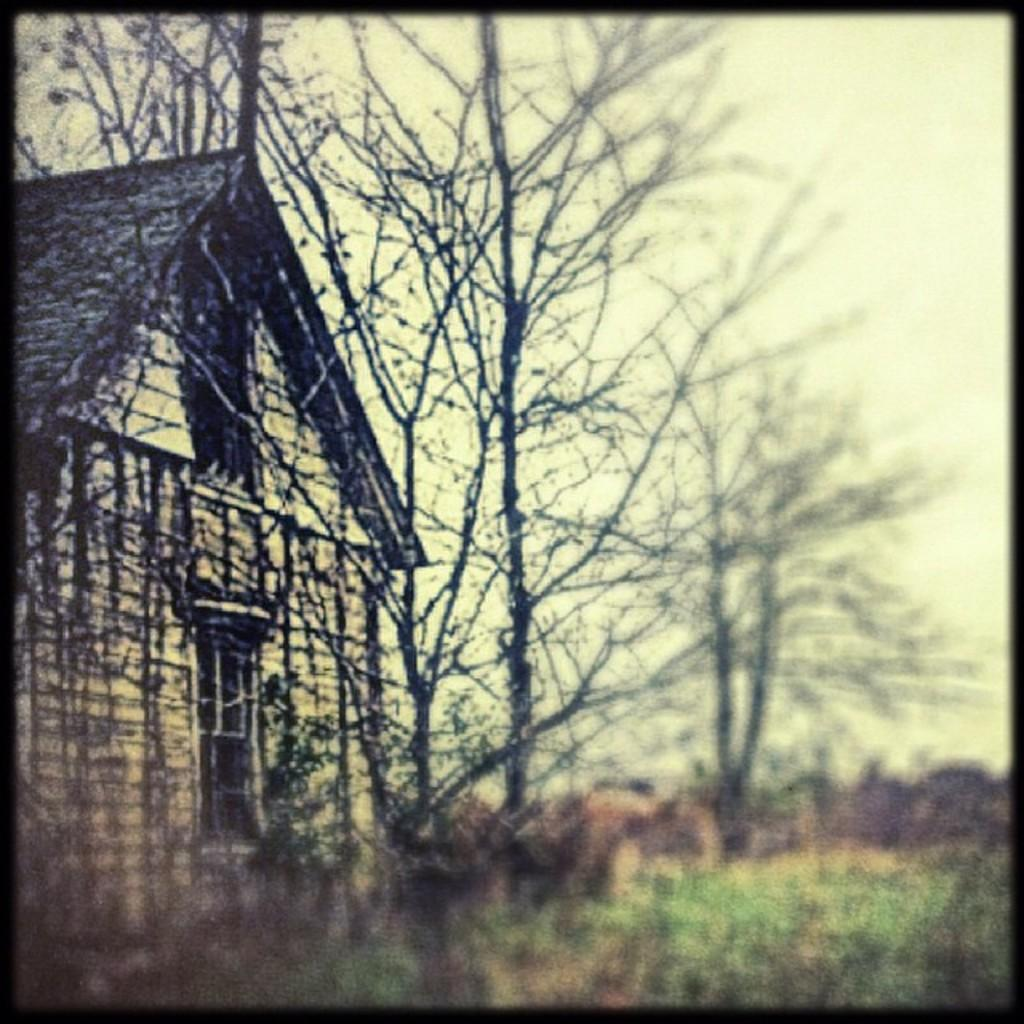What type of structure is visible in the picture? There is a house in the picture. What type of natural elements can be seen in the picture? There are trees in the picture. What else can be seen in the picture besides the house and trees? There are stems in the picture. Can you describe the bottom part of the picture? The bottom of the picture has a blurred view. What type of soap is being used to clean the bricks in the picture? There are no bricks or soap present in the picture; it features a house, trees, and stems. 